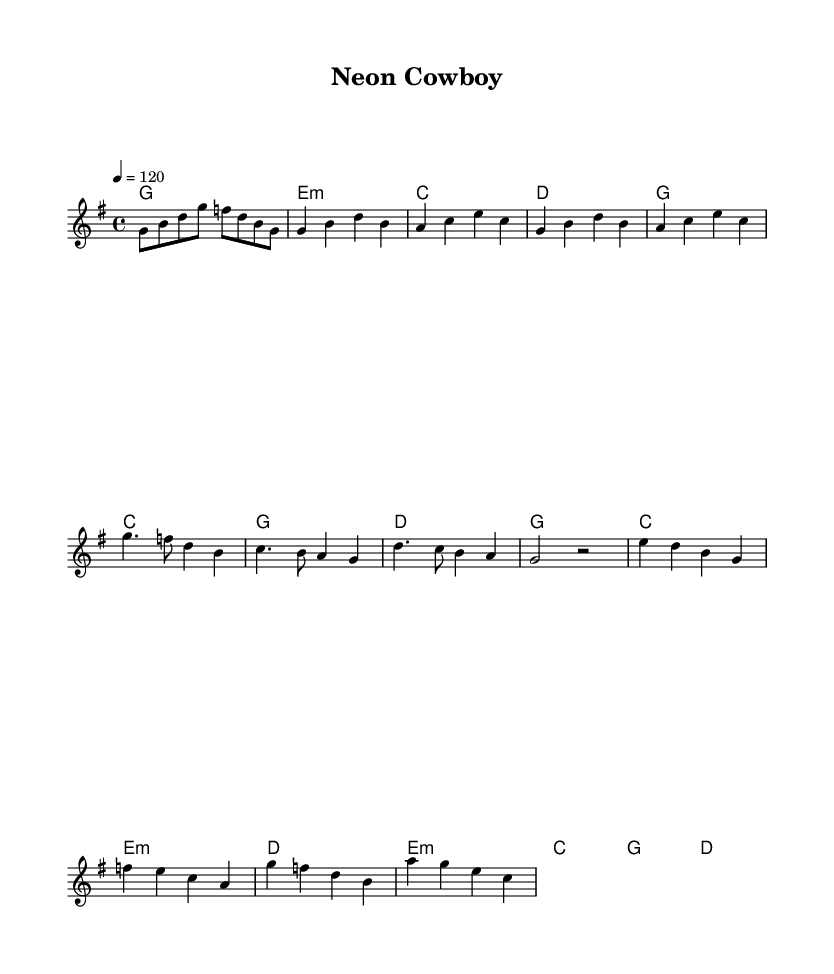What is the key signature of this music? The key signature is G major, which has one sharp (F#) and corresponds to the line where the key is indicated.
Answer: G major What is the time signature of this music? The time signature is 4/4, as indicated at the beginning of the score, showing four beats per measure.
Answer: 4/4 What is the tempo marking for this piece? The tempo marking is quarter note equals 120, shown at the beginning indicating the speed of the piece.
Answer: 120 How many measures are in the verse? There are four measures in the verse section, as seen in the layout dividing the verse into individual measures.
Answer: 4 Which chord is played during the chorus's first measure? The first chord of the chorus is G major, indicated by the chord symbol above the staff at the start of the chorus section.
Answer: G What is the last chord used in the bridge? The last chord used in the bridge is D major, seen in the chord symbols after the notes in the bridge section.
Answer: D How many distinct sections are there in this piece? There are four distinct sections in this piece: Intro, Verse, Chorus, and Bridge, each marked and identifiable through the structure of the music.
Answer: 4 